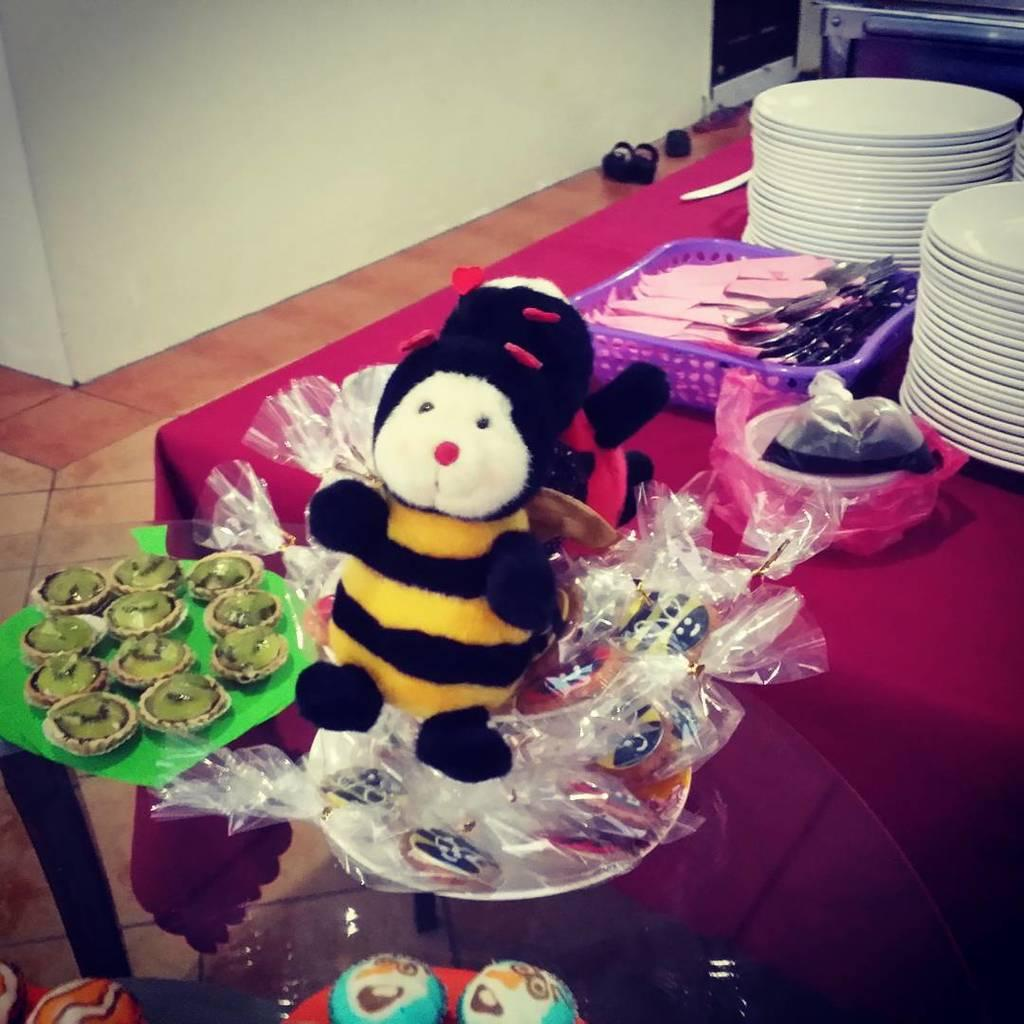What is located in the foreground of the image? There is a toy in the foreground of the image. Where are the plates placed in the image? The plates are placed on a table on the right side of the image. What type of stew is being served on the plates in the image? There is no stew present in the image; the plates are empty. What connection can be made between the toy and the plates in the image? There is no direct connection between the toy and the plates in the image, as they are separate subjects. 